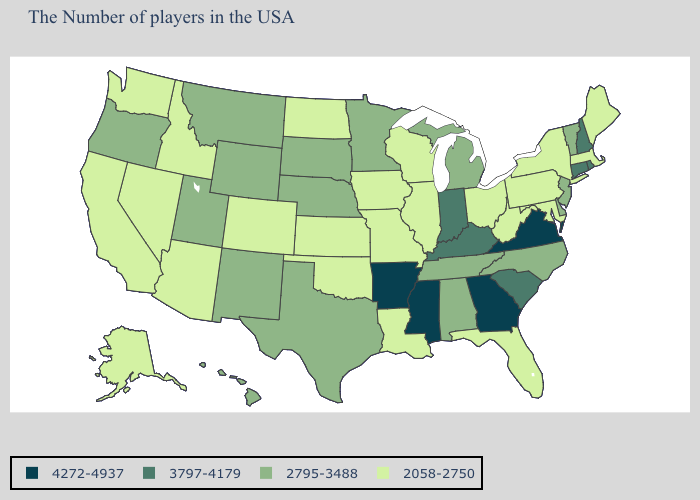Name the states that have a value in the range 4272-4937?
Concise answer only. Virginia, Georgia, Mississippi, Arkansas. What is the highest value in the South ?
Short answer required. 4272-4937. Name the states that have a value in the range 2795-3488?
Short answer required. Vermont, New Jersey, Delaware, North Carolina, Michigan, Alabama, Tennessee, Minnesota, Nebraska, Texas, South Dakota, Wyoming, New Mexico, Utah, Montana, Oregon, Hawaii. What is the value of New Hampshire?
Quick response, please. 3797-4179. What is the highest value in the West ?
Answer briefly. 2795-3488. What is the value of Kansas?
Short answer required. 2058-2750. What is the value of Maryland?
Write a very short answer. 2058-2750. Does Arizona have the highest value in the West?
Keep it brief. No. What is the value of Illinois?
Quick response, please. 2058-2750. How many symbols are there in the legend?
Give a very brief answer. 4. Which states have the highest value in the USA?
Write a very short answer. Virginia, Georgia, Mississippi, Arkansas. Which states hav the highest value in the MidWest?
Short answer required. Indiana. Does the first symbol in the legend represent the smallest category?
Answer briefly. No. Name the states that have a value in the range 3797-4179?
Keep it brief. Rhode Island, New Hampshire, Connecticut, South Carolina, Kentucky, Indiana. Name the states that have a value in the range 2795-3488?
Give a very brief answer. Vermont, New Jersey, Delaware, North Carolina, Michigan, Alabama, Tennessee, Minnesota, Nebraska, Texas, South Dakota, Wyoming, New Mexico, Utah, Montana, Oregon, Hawaii. 